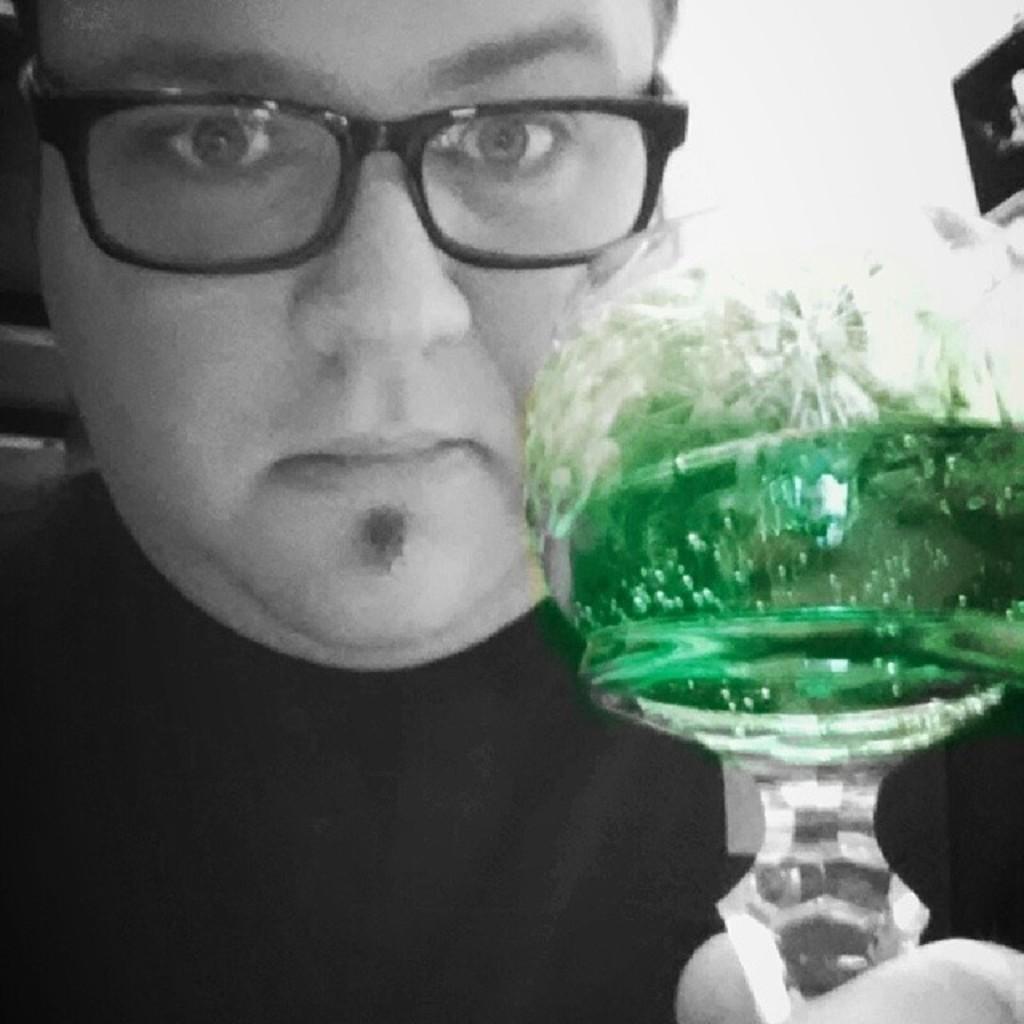Describe this image in one or two sentences. In this image, we can see a man, he is wearing specs, there is a blur background. 